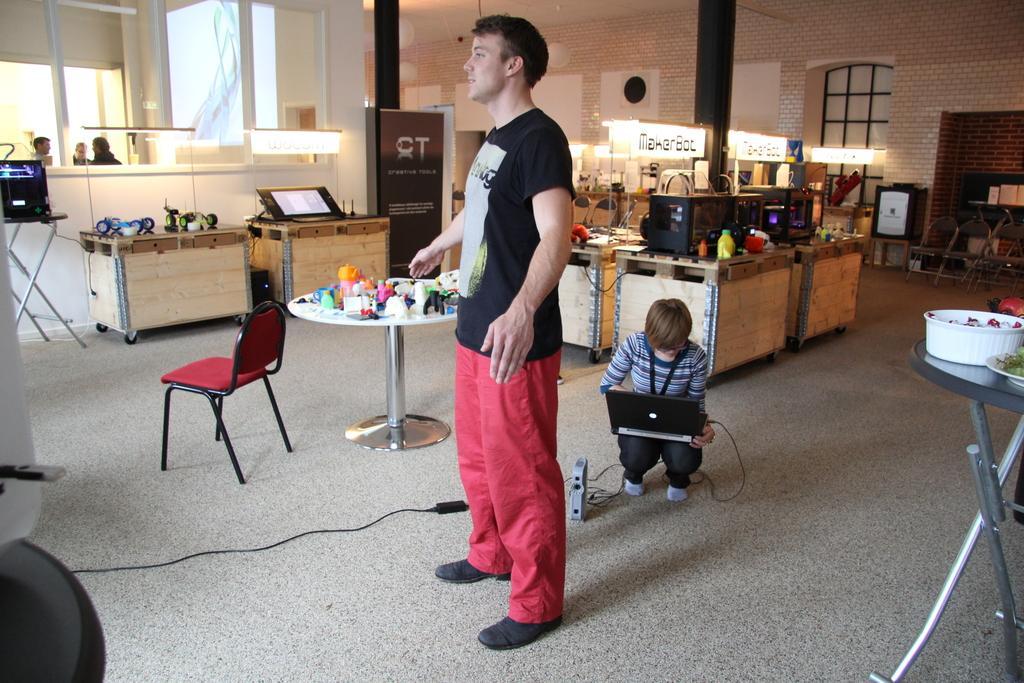Describe this image in one or two sentences. In the image we can see there is a person who is standing and behind there is a woman who is sitting and holding laptop in her lap and at the back there are electronic items on the table. There are water bottle and other household related items. On the table there is plate in which there are food items and in bowl there are other food items. At the back there are chairs kept and the wall is made up of bricks and there is red colour chair and on table there are other household items and over here we can see there are people who are standing. 